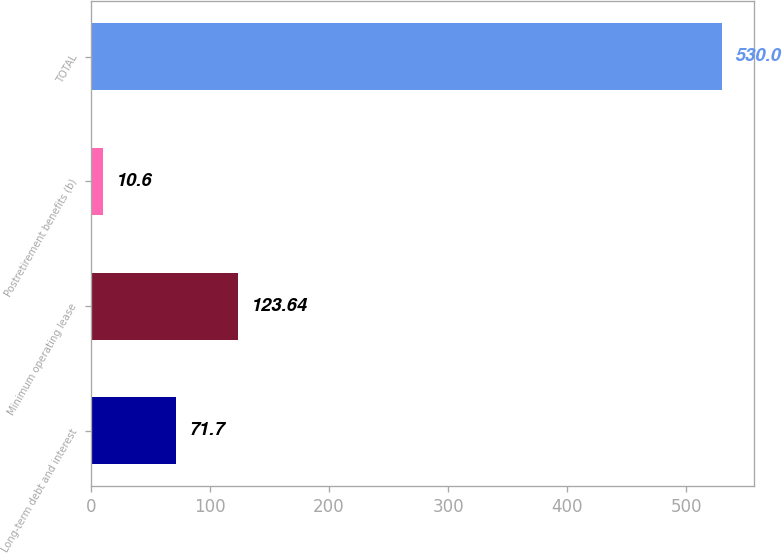Convert chart to OTSL. <chart><loc_0><loc_0><loc_500><loc_500><bar_chart><fcel>Long-term debt and interest<fcel>Minimum operating lease<fcel>Postretirement benefits (b)<fcel>TOTAL<nl><fcel>71.7<fcel>123.64<fcel>10.6<fcel>530<nl></chart> 